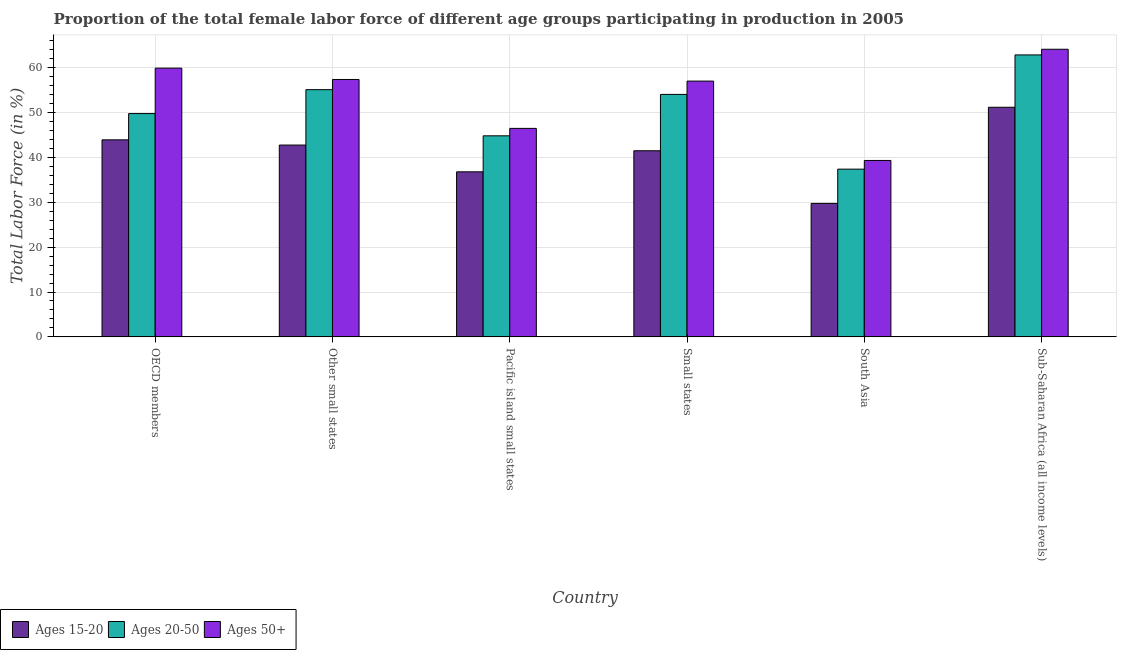How many different coloured bars are there?
Your answer should be compact. 3. What is the label of the 3rd group of bars from the left?
Your answer should be very brief. Pacific island small states. What is the percentage of female labor force within the age group 20-50 in Pacific island small states?
Keep it short and to the point. 44.81. Across all countries, what is the maximum percentage of female labor force above age 50?
Give a very brief answer. 64.11. Across all countries, what is the minimum percentage of female labor force within the age group 20-50?
Your response must be concise. 37.38. In which country was the percentage of female labor force above age 50 maximum?
Make the answer very short. Sub-Saharan Africa (all income levels). In which country was the percentage of female labor force above age 50 minimum?
Offer a very short reply. South Asia. What is the total percentage of female labor force within the age group 15-20 in the graph?
Ensure brevity in your answer.  245.87. What is the difference between the percentage of female labor force within the age group 15-20 in Small states and that in South Asia?
Provide a short and direct response. 11.74. What is the difference between the percentage of female labor force within the age group 15-20 in South Asia and the percentage of female labor force within the age group 20-50 in Other small states?
Ensure brevity in your answer.  -25.35. What is the average percentage of female labor force within the age group 20-50 per country?
Your response must be concise. 50.66. What is the difference between the percentage of female labor force above age 50 and percentage of female labor force within the age group 20-50 in Pacific island small states?
Your answer should be compact. 1.66. In how many countries, is the percentage of female labor force above age 50 greater than 40 %?
Keep it short and to the point. 5. What is the ratio of the percentage of female labor force within the age group 15-20 in Other small states to that in Pacific island small states?
Provide a succinct answer. 1.16. What is the difference between the highest and the second highest percentage of female labor force within the age group 20-50?
Your response must be concise. 7.74. What is the difference between the highest and the lowest percentage of female labor force within the age group 15-20?
Keep it short and to the point. 21.43. In how many countries, is the percentage of female labor force above age 50 greater than the average percentage of female labor force above age 50 taken over all countries?
Your answer should be compact. 4. What does the 3rd bar from the left in South Asia represents?
Your answer should be compact. Ages 50+. What does the 1st bar from the right in South Asia represents?
Ensure brevity in your answer.  Ages 50+. Is it the case that in every country, the sum of the percentage of female labor force within the age group 15-20 and percentage of female labor force within the age group 20-50 is greater than the percentage of female labor force above age 50?
Keep it short and to the point. Yes. How many bars are there?
Your answer should be very brief. 18. How many countries are there in the graph?
Your response must be concise. 6. Are the values on the major ticks of Y-axis written in scientific E-notation?
Offer a very short reply. No. How many legend labels are there?
Offer a terse response. 3. What is the title of the graph?
Your response must be concise. Proportion of the total female labor force of different age groups participating in production in 2005. What is the label or title of the Y-axis?
Keep it short and to the point. Total Labor Force (in %). What is the Total Labor Force (in %) of Ages 15-20 in OECD members?
Offer a very short reply. 43.92. What is the Total Labor Force (in %) of Ages 20-50 in OECD members?
Your answer should be compact. 49.77. What is the Total Labor Force (in %) in Ages 50+ in OECD members?
Provide a short and direct response. 59.9. What is the Total Labor Force (in %) in Ages 15-20 in Other small states?
Offer a terse response. 42.75. What is the Total Labor Force (in %) of Ages 20-50 in Other small states?
Provide a short and direct response. 55.1. What is the Total Labor Force (in %) in Ages 50+ in Other small states?
Ensure brevity in your answer.  57.37. What is the Total Labor Force (in %) of Ages 15-20 in Pacific island small states?
Provide a short and direct response. 36.79. What is the Total Labor Force (in %) in Ages 20-50 in Pacific island small states?
Provide a succinct answer. 44.81. What is the Total Labor Force (in %) in Ages 50+ in Pacific island small states?
Provide a short and direct response. 46.47. What is the Total Labor Force (in %) in Ages 15-20 in Small states?
Provide a short and direct response. 41.49. What is the Total Labor Force (in %) in Ages 20-50 in Small states?
Provide a short and direct response. 54.04. What is the Total Labor Force (in %) of Ages 50+ in Small states?
Offer a very short reply. 57.01. What is the Total Labor Force (in %) of Ages 15-20 in South Asia?
Your answer should be very brief. 29.75. What is the Total Labor Force (in %) in Ages 20-50 in South Asia?
Your response must be concise. 37.38. What is the Total Labor Force (in %) in Ages 50+ in South Asia?
Provide a short and direct response. 39.32. What is the Total Labor Force (in %) of Ages 15-20 in Sub-Saharan Africa (all income levels)?
Ensure brevity in your answer.  51.18. What is the Total Labor Force (in %) of Ages 20-50 in Sub-Saharan Africa (all income levels)?
Make the answer very short. 62.85. What is the Total Labor Force (in %) of Ages 50+ in Sub-Saharan Africa (all income levels)?
Your answer should be very brief. 64.11. Across all countries, what is the maximum Total Labor Force (in %) of Ages 15-20?
Your response must be concise. 51.18. Across all countries, what is the maximum Total Labor Force (in %) in Ages 20-50?
Provide a succinct answer. 62.85. Across all countries, what is the maximum Total Labor Force (in %) in Ages 50+?
Offer a very short reply. 64.11. Across all countries, what is the minimum Total Labor Force (in %) in Ages 15-20?
Make the answer very short. 29.75. Across all countries, what is the minimum Total Labor Force (in %) of Ages 20-50?
Give a very brief answer. 37.38. Across all countries, what is the minimum Total Labor Force (in %) of Ages 50+?
Keep it short and to the point. 39.32. What is the total Total Labor Force (in %) in Ages 15-20 in the graph?
Provide a short and direct response. 245.87. What is the total Total Labor Force (in %) of Ages 20-50 in the graph?
Provide a short and direct response. 303.96. What is the total Total Labor Force (in %) of Ages 50+ in the graph?
Your response must be concise. 324.18. What is the difference between the Total Labor Force (in %) in Ages 15-20 in OECD members and that in Other small states?
Ensure brevity in your answer.  1.16. What is the difference between the Total Labor Force (in %) of Ages 20-50 in OECD members and that in Other small states?
Keep it short and to the point. -5.33. What is the difference between the Total Labor Force (in %) in Ages 50+ in OECD members and that in Other small states?
Your response must be concise. 2.53. What is the difference between the Total Labor Force (in %) of Ages 15-20 in OECD members and that in Pacific island small states?
Keep it short and to the point. 7.13. What is the difference between the Total Labor Force (in %) of Ages 20-50 in OECD members and that in Pacific island small states?
Your response must be concise. 4.96. What is the difference between the Total Labor Force (in %) in Ages 50+ in OECD members and that in Pacific island small states?
Ensure brevity in your answer.  13.43. What is the difference between the Total Labor Force (in %) of Ages 15-20 in OECD members and that in Small states?
Ensure brevity in your answer.  2.43. What is the difference between the Total Labor Force (in %) in Ages 20-50 in OECD members and that in Small states?
Offer a terse response. -4.27. What is the difference between the Total Labor Force (in %) in Ages 50+ in OECD members and that in Small states?
Offer a very short reply. 2.89. What is the difference between the Total Labor Force (in %) of Ages 15-20 in OECD members and that in South Asia?
Your answer should be very brief. 14.17. What is the difference between the Total Labor Force (in %) of Ages 20-50 in OECD members and that in South Asia?
Offer a terse response. 12.39. What is the difference between the Total Labor Force (in %) of Ages 50+ in OECD members and that in South Asia?
Offer a very short reply. 20.58. What is the difference between the Total Labor Force (in %) in Ages 15-20 in OECD members and that in Sub-Saharan Africa (all income levels)?
Your response must be concise. -7.26. What is the difference between the Total Labor Force (in %) of Ages 20-50 in OECD members and that in Sub-Saharan Africa (all income levels)?
Your answer should be compact. -13.08. What is the difference between the Total Labor Force (in %) of Ages 50+ in OECD members and that in Sub-Saharan Africa (all income levels)?
Offer a terse response. -4.21. What is the difference between the Total Labor Force (in %) of Ages 15-20 in Other small states and that in Pacific island small states?
Offer a terse response. 5.97. What is the difference between the Total Labor Force (in %) in Ages 20-50 in Other small states and that in Pacific island small states?
Offer a very short reply. 10.29. What is the difference between the Total Labor Force (in %) of Ages 50+ in Other small states and that in Pacific island small states?
Make the answer very short. 10.9. What is the difference between the Total Labor Force (in %) in Ages 15-20 in Other small states and that in Small states?
Keep it short and to the point. 1.27. What is the difference between the Total Labor Force (in %) of Ages 20-50 in Other small states and that in Small states?
Give a very brief answer. 1.06. What is the difference between the Total Labor Force (in %) in Ages 50+ in Other small states and that in Small states?
Offer a terse response. 0.36. What is the difference between the Total Labor Force (in %) of Ages 15-20 in Other small states and that in South Asia?
Keep it short and to the point. 13.01. What is the difference between the Total Labor Force (in %) of Ages 20-50 in Other small states and that in South Asia?
Keep it short and to the point. 17.72. What is the difference between the Total Labor Force (in %) of Ages 50+ in Other small states and that in South Asia?
Your response must be concise. 18.05. What is the difference between the Total Labor Force (in %) in Ages 15-20 in Other small states and that in Sub-Saharan Africa (all income levels)?
Give a very brief answer. -8.42. What is the difference between the Total Labor Force (in %) of Ages 20-50 in Other small states and that in Sub-Saharan Africa (all income levels)?
Offer a terse response. -7.74. What is the difference between the Total Labor Force (in %) in Ages 50+ in Other small states and that in Sub-Saharan Africa (all income levels)?
Your answer should be very brief. -6.73. What is the difference between the Total Labor Force (in %) of Ages 15-20 in Pacific island small states and that in Small states?
Ensure brevity in your answer.  -4.7. What is the difference between the Total Labor Force (in %) in Ages 20-50 in Pacific island small states and that in Small states?
Your answer should be very brief. -9.23. What is the difference between the Total Labor Force (in %) of Ages 50+ in Pacific island small states and that in Small states?
Ensure brevity in your answer.  -10.54. What is the difference between the Total Labor Force (in %) in Ages 15-20 in Pacific island small states and that in South Asia?
Your response must be concise. 7.04. What is the difference between the Total Labor Force (in %) of Ages 20-50 in Pacific island small states and that in South Asia?
Ensure brevity in your answer.  7.43. What is the difference between the Total Labor Force (in %) in Ages 50+ in Pacific island small states and that in South Asia?
Make the answer very short. 7.15. What is the difference between the Total Labor Force (in %) in Ages 15-20 in Pacific island small states and that in Sub-Saharan Africa (all income levels)?
Offer a terse response. -14.39. What is the difference between the Total Labor Force (in %) of Ages 20-50 in Pacific island small states and that in Sub-Saharan Africa (all income levels)?
Provide a succinct answer. -18.03. What is the difference between the Total Labor Force (in %) in Ages 50+ in Pacific island small states and that in Sub-Saharan Africa (all income levels)?
Provide a short and direct response. -17.64. What is the difference between the Total Labor Force (in %) in Ages 15-20 in Small states and that in South Asia?
Your answer should be compact. 11.74. What is the difference between the Total Labor Force (in %) of Ages 20-50 in Small states and that in South Asia?
Your response must be concise. 16.66. What is the difference between the Total Labor Force (in %) in Ages 50+ in Small states and that in South Asia?
Ensure brevity in your answer.  17.69. What is the difference between the Total Labor Force (in %) in Ages 15-20 in Small states and that in Sub-Saharan Africa (all income levels)?
Your answer should be very brief. -9.69. What is the difference between the Total Labor Force (in %) in Ages 20-50 in Small states and that in Sub-Saharan Africa (all income levels)?
Offer a very short reply. -8.8. What is the difference between the Total Labor Force (in %) of Ages 50+ in Small states and that in Sub-Saharan Africa (all income levels)?
Keep it short and to the point. -7.1. What is the difference between the Total Labor Force (in %) of Ages 15-20 in South Asia and that in Sub-Saharan Africa (all income levels)?
Make the answer very short. -21.43. What is the difference between the Total Labor Force (in %) of Ages 20-50 in South Asia and that in Sub-Saharan Africa (all income levels)?
Your response must be concise. -25.46. What is the difference between the Total Labor Force (in %) of Ages 50+ in South Asia and that in Sub-Saharan Africa (all income levels)?
Your answer should be very brief. -24.79. What is the difference between the Total Labor Force (in %) of Ages 15-20 in OECD members and the Total Labor Force (in %) of Ages 20-50 in Other small states?
Provide a succinct answer. -11.18. What is the difference between the Total Labor Force (in %) in Ages 15-20 in OECD members and the Total Labor Force (in %) in Ages 50+ in Other small states?
Keep it short and to the point. -13.46. What is the difference between the Total Labor Force (in %) of Ages 20-50 in OECD members and the Total Labor Force (in %) of Ages 50+ in Other small states?
Keep it short and to the point. -7.6. What is the difference between the Total Labor Force (in %) of Ages 15-20 in OECD members and the Total Labor Force (in %) of Ages 20-50 in Pacific island small states?
Make the answer very short. -0.9. What is the difference between the Total Labor Force (in %) of Ages 15-20 in OECD members and the Total Labor Force (in %) of Ages 50+ in Pacific island small states?
Keep it short and to the point. -2.55. What is the difference between the Total Labor Force (in %) in Ages 20-50 in OECD members and the Total Labor Force (in %) in Ages 50+ in Pacific island small states?
Your answer should be compact. 3.3. What is the difference between the Total Labor Force (in %) in Ages 15-20 in OECD members and the Total Labor Force (in %) in Ages 20-50 in Small states?
Offer a very short reply. -10.13. What is the difference between the Total Labor Force (in %) of Ages 15-20 in OECD members and the Total Labor Force (in %) of Ages 50+ in Small states?
Offer a very short reply. -13.09. What is the difference between the Total Labor Force (in %) in Ages 20-50 in OECD members and the Total Labor Force (in %) in Ages 50+ in Small states?
Your answer should be very brief. -7.24. What is the difference between the Total Labor Force (in %) of Ages 15-20 in OECD members and the Total Labor Force (in %) of Ages 20-50 in South Asia?
Provide a succinct answer. 6.53. What is the difference between the Total Labor Force (in %) of Ages 15-20 in OECD members and the Total Labor Force (in %) of Ages 50+ in South Asia?
Offer a terse response. 4.6. What is the difference between the Total Labor Force (in %) in Ages 20-50 in OECD members and the Total Labor Force (in %) in Ages 50+ in South Asia?
Your answer should be very brief. 10.45. What is the difference between the Total Labor Force (in %) of Ages 15-20 in OECD members and the Total Labor Force (in %) of Ages 20-50 in Sub-Saharan Africa (all income levels)?
Provide a succinct answer. -18.93. What is the difference between the Total Labor Force (in %) in Ages 15-20 in OECD members and the Total Labor Force (in %) in Ages 50+ in Sub-Saharan Africa (all income levels)?
Make the answer very short. -20.19. What is the difference between the Total Labor Force (in %) in Ages 20-50 in OECD members and the Total Labor Force (in %) in Ages 50+ in Sub-Saharan Africa (all income levels)?
Make the answer very short. -14.34. What is the difference between the Total Labor Force (in %) of Ages 15-20 in Other small states and the Total Labor Force (in %) of Ages 20-50 in Pacific island small states?
Provide a short and direct response. -2.06. What is the difference between the Total Labor Force (in %) of Ages 15-20 in Other small states and the Total Labor Force (in %) of Ages 50+ in Pacific island small states?
Offer a terse response. -3.71. What is the difference between the Total Labor Force (in %) of Ages 20-50 in Other small states and the Total Labor Force (in %) of Ages 50+ in Pacific island small states?
Keep it short and to the point. 8.63. What is the difference between the Total Labor Force (in %) in Ages 15-20 in Other small states and the Total Labor Force (in %) in Ages 20-50 in Small states?
Keep it short and to the point. -11.29. What is the difference between the Total Labor Force (in %) in Ages 15-20 in Other small states and the Total Labor Force (in %) in Ages 50+ in Small states?
Ensure brevity in your answer.  -14.26. What is the difference between the Total Labor Force (in %) of Ages 20-50 in Other small states and the Total Labor Force (in %) of Ages 50+ in Small states?
Your response must be concise. -1.91. What is the difference between the Total Labor Force (in %) in Ages 15-20 in Other small states and the Total Labor Force (in %) in Ages 20-50 in South Asia?
Offer a terse response. 5.37. What is the difference between the Total Labor Force (in %) in Ages 15-20 in Other small states and the Total Labor Force (in %) in Ages 50+ in South Asia?
Offer a terse response. 3.43. What is the difference between the Total Labor Force (in %) in Ages 20-50 in Other small states and the Total Labor Force (in %) in Ages 50+ in South Asia?
Offer a very short reply. 15.78. What is the difference between the Total Labor Force (in %) of Ages 15-20 in Other small states and the Total Labor Force (in %) of Ages 20-50 in Sub-Saharan Africa (all income levels)?
Provide a short and direct response. -20.09. What is the difference between the Total Labor Force (in %) in Ages 15-20 in Other small states and the Total Labor Force (in %) in Ages 50+ in Sub-Saharan Africa (all income levels)?
Ensure brevity in your answer.  -21.35. What is the difference between the Total Labor Force (in %) in Ages 20-50 in Other small states and the Total Labor Force (in %) in Ages 50+ in Sub-Saharan Africa (all income levels)?
Keep it short and to the point. -9.01. What is the difference between the Total Labor Force (in %) in Ages 15-20 in Pacific island small states and the Total Labor Force (in %) in Ages 20-50 in Small states?
Give a very brief answer. -17.26. What is the difference between the Total Labor Force (in %) of Ages 15-20 in Pacific island small states and the Total Labor Force (in %) of Ages 50+ in Small states?
Offer a very short reply. -20.22. What is the difference between the Total Labor Force (in %) of Ages 20-50 in Pacific island small states and the Total Labor Force (in %) of Ages 50+ in Small states?
Offer a terse response. -12.2. What is the difference between the Total Labor Force (in %) in Ages 15-20 in Pacific island small states and the Total Labor Force (in %) in Ages 20-50 in South Asia?
Offer a terse response. -0.6. What is the difference between the Total Labor Force (in %) of Ages 15-20 in Pacific island small states and the Total Labor Force (in %) of Ages 50+ in South Asia?
Offer a very short reply. -2.53. What is the difference between the Total Labor Force (in %) of Ages 20-50 in Pacific island small states and the Total Labor Force (in %) of Ages 50+ in South Asia?
Your response must be concise. 5.49. What is the difference between the Total Labor Force (in %) in Ages 15-20 in Pacific island small states and the Total Labor Force (in %) in Ages 20-50 in Sub-Saharan Africa (all income levels)?
Your answer should be very brief. -26.06. What is the difference between the Total Labor Force (in %) in Ages 15-20 in Pacific island small states and the Total Labor Force (in %) in Ages 50+ in Sub-Saharan Africa (all income levels)?
Ensure brevity in your answer.  -27.32. What is the difference between the Total Labor Force (in %) in Ages 20-50 in Pacific island small states and the Total Labor Force (in %) in Ages 50+ in Sub-Saharan Africa (all income levels)?
Your response must be concise. -19.29. What is the difference between the Total Labor Force (in %) in Ages 15-20 in Small states and the Total Labor Force (in %) in Ages 20-50 in South Asia?
Keep it short and to the point. 4.1. What is the difference between the Total Labor Force (in %) in Ages 15-20 in Small states and the Total Labor Force (in %) in Ages 50+ in South Asia?
Provide a short and direct response. 2.17. What is the difference between the Total Labor Force (in %) in Ages 20-50 in Small states and the Total Labor Force (in %) in Ages 50+ in South Asia?
Provide a short and direct response. 14.72. What is the difference between the Total Labor Force (in %) of Ages 15-20 in Small states and the Total Labor Force (in %) of Ages 20-50 in Sub-Saharan Africa (all income levels)?
Your answer should be very brief. -21.36. What is the difference between the Total Labor Force (in %) of Ages 15-20 in Small states and the Total Labor Force (in %) of Ages 50+ in Sub-Saharan Africa (all income levels)?
Your answer should be compact. -22.62. What is the difference between the Total Labor Force (in %) in Ages 20-50 in Small states and the Total Labor Force (in %) in Ages 50+ in Sub-Saharan Africa (all income levels)?
Keep it short and to the point. -10.06. What is the difference between the Total Labor Force (in %) in Ages 15-20 in South Asia and the Total Labor Force (in %) in Ages 20-50 in Sub-Saharan Africa (all income levels)?
Your response must be concise. -33.1. What is the difference between the Total Labor Force (in %) in Ages 15-20 in South Asia and the Total Labor Force (in %) in Ages 50+ in Sub-Saharan Africa (all income levels)?
Offer a very short reply. -34.36. What is the difference between the Total Labor Force (in %) of Ages 20-50 in South Asia and the Total Labor Force (in %) of Ages 50+ in Sub-Saharan Africa (all income levels)?
Keep it short and to the point. -26.72. What is the average Total Labor Force (in %) of Ages 15-20 per country?
Your response must be concise. 40.98. What is the average Total Labor Force (in %) of Ages 20-50 per country?
Your answer should be very brief. 50.66. What is the average Total Labor Force (in %) in Ages 50+ per country?
Keep it short and to the point. 54.03. What is the difference between the Total Labor Force (in %) of Ages 15-20 and Total Labor Force (in %) of Ages 20-50 in OECD members?
Keep it short and to the point. -5.85. What is the difference between the Total Labor Force (in %) of Ages 15-20 and Total Labor Force (in %) of Ages 50+ in OECD members?
Offer a very short reply. -15.98. What is the difference between the Total Labor Force (in %) of Ages 20-50 and Total Labor Force (in %) of Ages 50+ in OECD members?
Offer a terse response. -10.13. What is the difference between the Total Labor Force (in %) of Ages 15-20 and Total Labor Force (in %) of Ages 20-50 in Other small states?
Ensure brevity in your answer.  -12.35. What is the difference between the Total Labor Force (in %) of Ages 15-20 and Total Labor Force (in %) of Ages 50+ in Other small states?
Provide a short and direct response. -14.62. What is the difference between the Total Labor Force (in %) of Ages 20-50 and Total Labor Force (in %) of Ages 50+ in Other small states?
Offer a very short reply. -2.27. What is the difference between the Total Labor Force (in %) of Ages 15-20 and Total Labor Force (in %) of Ages 20-50 in Pacific island small states?
Your answer should be compact. -8.03. What is the difference between the Total Labor Force (in %) in Ages 15-20 and Total Labor Force (in %) in Ages 50+ in Pacific island small states?
Give a very brief answer. -9.68. What is the difference between the Total Labor Force (in %) in Ages 20-50 and Total Labor Force (in %) in Ages 50+ in Pacific island small states?
Make the answer very short. -1.66. What is the difference between the Total Labor Force (in %) of Ages 15-20 and Total Labor Force (in %) of Ages 20-50 in Small states?
Ensure brevity in your answer.  -12.56. What is the difference between the Total Labor Force (in %) in Ages 15-20 and Total Labor Force (in %) in Ages 50+ in Small states?
Give a very brief answer. -15.53. What is the difference between the Total Labor Force (in %) in Ages 20-50 and Total Labor Force (in %) in Ages 50+ in Small states?
Give a very brief answer. -2.97. What is the difference between the Total Labor Force (in %) of Ages 15-20 and Total Labor Force (in %) of Ages 20-50 in South Asia?
Provide a short and direct response. -7.64. What is the difference between the Total Labor Force (in %) in Ages 15-20 and Total Labor Force (in %) in Ages 50+ in South Asia?
Keep it short and to the point. -9.57. What is the difference between the Total Labor Force (in %) of Ages 20-50 and Total Labor Force (in %) of Ages 50+ in South Asia?
Offer a terse response. -1.94. What is the difference between the Total Labor Force (in %) of Ages 15-20 and Total Labor Force (in %) of Ages 20-50 in Sub-Saharan Africa (all income levels)?
Your answer should be compact. -11.67. What is the difference between the Total Labor Force (in %) of Ages 15-20 and Total Labor Force (in %) of Ages 50+ in Sub-Saharan Africa (all income levels)?
Give a very brief answer. -12.93. What is the difference between the Total Labor Force (in %) in Ages 20-50 and Total Labor Force (in %) in Ages 50+ in Sub-Saharan Africa (all income levels)?
Ensure brevity in your answer.  -1.26. What is the ratio of the Total Labor Force (in %) of Ages 15-20 in OECD members to that in Other small states?
Your answer should be very brief. 1.03. What is the ratio of the Total Labor Force (in %) of Ages 20-50 in OECD members to that in Other small states?
Offer a very short reply. 0.9. What is the ratio of the Total Labor Force (in %) of Ages 50+ in OECD members to that in Other small states?
Provide a short and direct response. 1.04. What is the ratio of the Total Labor Force (in %) of Ages 15-20 in OECD members to that in Pacific island small states?
Your answer should be compact. 1.19. What is the ratio of the Total Labor Force (in %) of Ages 20-50 in OECD members to that in Pacific island small states?
Offer a very short reply. 1.11. What is the ratio of the Total Labor Force (in %) of Ages 50+ in OECD members to that in Pacific island small states?
Your answer should be compact. 1.29. What is the ratio of the Total Labor Force (in %) of Ages 15-20 in OECD members to that in Small states?
Your answer should be compact. 1.06. What is the ratio of the Total Labor Force (in %) of Ages 20-50 in OECD members to that in Small states?
Give a very brief answer. 0.92. What is the ratio of the Total Labor Force (in %) of Ages 50+ in OECD members to that in Small states?
Provide a short and direct response. 1.05. What is the ratio of the Total Labor Force (in %) of Ages 15-20 in OECD members to that in South Asia?
Give a very brief answer. 1.48. What is the ratio of the Total Labor Force (in %) of Ages 20-50 in OECD members to that in South Asia?
Give a very brief answer. 1.33. What is the ratio of the Total Labor Force (in %) of Ages 50+ in OECD members to that in South Asia?
Your response must be concise. 1.52. What is the ratio of the Total Labor Force (in %) of Ages 15-20 in OECD members to that in Sub-Saharan Africa (all income levels)?
Provide a succinct answer. 0.86. What is the ratio of the Total Labor Force (in %) of Ages 20-50 in OECD members to that in Sub-Saharan Africa (all income levels)?
Ensure brevity in your answer.  0.79. What is the ratio of the Total Labor Force (in %) in Ages 50+ in OECD members to that in Sub-Saharan Africa (all income levels)?
Provide a short and direct response. 0.93. What is the ratio of the Total Labor Force (in %) in Ages 15-20 in Other small states to that in Pacific island small states?
Give a very brief answer. 1.16. What is the ratio of the Total Labor Force (in %) of Ages 20-50 in Other small states to that in Pacific island small states?
Ensure brevity in your answer.  1.23. What is the ratio of the Total Labor Force (in %) in Ages 50+ in Other small states to that in Pacific island small states?
Offer a very short reply. 1.23. What is the ratio of the Total Labor Force (in %) in Ages 15-20 in Other small states to that in Small states?
Keep it short and to the point. 1.03. What is the ratio of the Total Labor Force (in %) in Ages 20-50 in Other small states to that in Small states?
Your answer should be very brief. 1.02. What is the ratio of the Total Labor Force (in %) of Ages 50+ in Other small states to that in Small states?
Provide a succinct answer. 1.01. What is the ratio of the Total Labor Force (in %) of Ages 15-20 in Other small states to that in South Asia?
Provide a short and direct response. 1.44. What is the ratio of the Total Labor Force (in %) of Ages 20-50 in Other small states to that in South Asia?
Make the answer very short. 1.47. What is the ratio of the Total Labor Force (in %) in Ages 50+ in Other small states to that in South Asia?
Your response must be concise. 1.46. What is the ratio of the Total Labor Force (in %) in Ages 15-20 in Other small states to that in Sub-Saharan Africa (all income levels)?
Keep it short and to the point. 0.84. What is the ratio of the Total Labor Force (in %) in Ages 20-50 in Other small states to that in Sub-Saharan Africa (all income levels)?
Keep it short and to the point. 0.88. What is the ratio of the Total Labor Force (in %) in Ages 50+ in Other small states to that in Sub-Saharan Africa (all income levels)?
Keep it short and to the point. 0.9. What is the ratio of the Total Labor Force (in %) in Ages 15-20 in Pacific island small states to that in Small states?
Offer a very short reply. 0.89. What is the ratio of the Total Labor Force (in %) in Ages 20-50 in Pacific island small states to that in Small states?
Provide a short and direct response. 0.83. What is the ratio of the Total Labor Force (in %) of Ages 50+ in Pacific island small states to that in Small states?
Your response must be concise. 0.82. What is the ratio of the Total Labor Force (in %) in Ages 15-20 in Pacific island small states to that in South Asia?
Provide a succinct answer. 1.24. What is the ratio of the Total Labor Force (in %) of Ages 20-50 in Pacific island small states to that in South Asia?
Make the answer very short. 1.2. What is the ratio of the Total Labor Force (in %) in Ages 50+ in Pacific island small states to that in South Asia?
Your response must be concise. 1.18. What is the ratio of the Total Labor Force (in %) of Ages 15-20 in Pacific island small states to that in Sub-Saharan Africa (all income levels)?
Offer a very short reply. 0.72. What is the ratio of the Total Labor Force (in %) in Ages 20-50 in Pacific island small states to that in Sub-Saharan Africa (all income levels)?
Keep it short and to the point. 0.71. What is the ratio of the Total Labor Force (in %) of Ages 50+ in Pacific island small states to that in Sub-Saharan Africa (all income levels)?
Provide a succinct answer. 0.72. What is the ratio of the Total Labor Force (in %) of Ages 15-20 in Small states to that in South Asia?
Your answer should be very brief. 1.39. What is the ratio of the Total Labor Force (in %) of Ages 20-50 in Small states to that in South Asia?
Your response must be concise. 1.45. What is the ratio of the Total Labor Force (in %) of Ages 50+ in Small states to that in South Asia?
Offer a very short reply. 1.45. What is the ratio of the Total Labor Force (in %) of Ages 15-20 in Small states to that in Sub-Saharan Africa (all income levels)?
Give a very brief answer. 0.81. What is the ratio of the Total Labor Force (in %) in Ages 20-50 in Small states to that in Sub-Saharan Africa (all income levels)?
Your response must be concise. 0.86. What is the ratio of the Total Labor Force (in %) of Ages 50+ in Small states to that in Sub-Saharan Africa (all income levels)?
Your answer should be very brief. 0.89. What is the ratio of the Total Labor Force (in %) of Ages 15-20 in South Asia to that in Sub-Saharan Africa (all income levels)?
Give a very brief answer. 0.58. What is the ratio of the Total Labor Force (in %) of Ages 20-50 in South Asia to that in Sub-Saharan Africa (all income levels)?
Ensure brevity in your answer.  0.59. What is the ratio of the Total Labor Force (in %) of Ages 50+ in South Asia to that in Sub-Saharan Africa (all income levels)?
Keep it short and to the point. 0.61. What is the difference between the highest and the second highest Total Labor Force (in %) in Ages 15-20?
Your answer should be very brief. 7.26. What is the difference between the highest and the second highest Total Labor Force (in %) of Ages 20-50?
Make the answer very short. 7.74. What is the difference between the highest and the second highest Total Labor Force (in %) of Ages 50+?
Make the answer very short. 4.21. What is the difference between the highest and the lowest Total Labor Force (in %) in Ages 15-20?
Keep it short and to the point. 21.43. What is the difference between the highest and the lowest Total Labor Force (in %) of Ages 20-50?
Make the answer very short. 25.46. What is the difference between the highest and the lowest Total Labor Force (in %) of Ages 50+?
Provide a short and direct response. 24.79. 